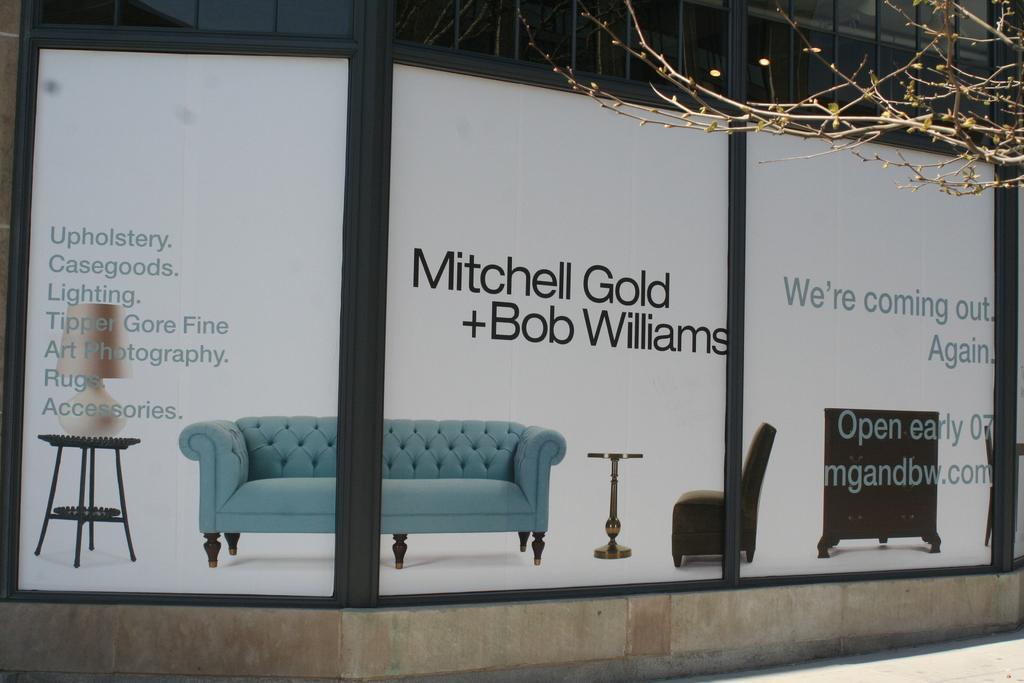In one or two sentences, can you explain what this image depicts? In this Image I see a building on which there are boards and I see a lamp on a stool, a sofa, chair, another stool and a table and there are few words on it and I see a tree over here. 